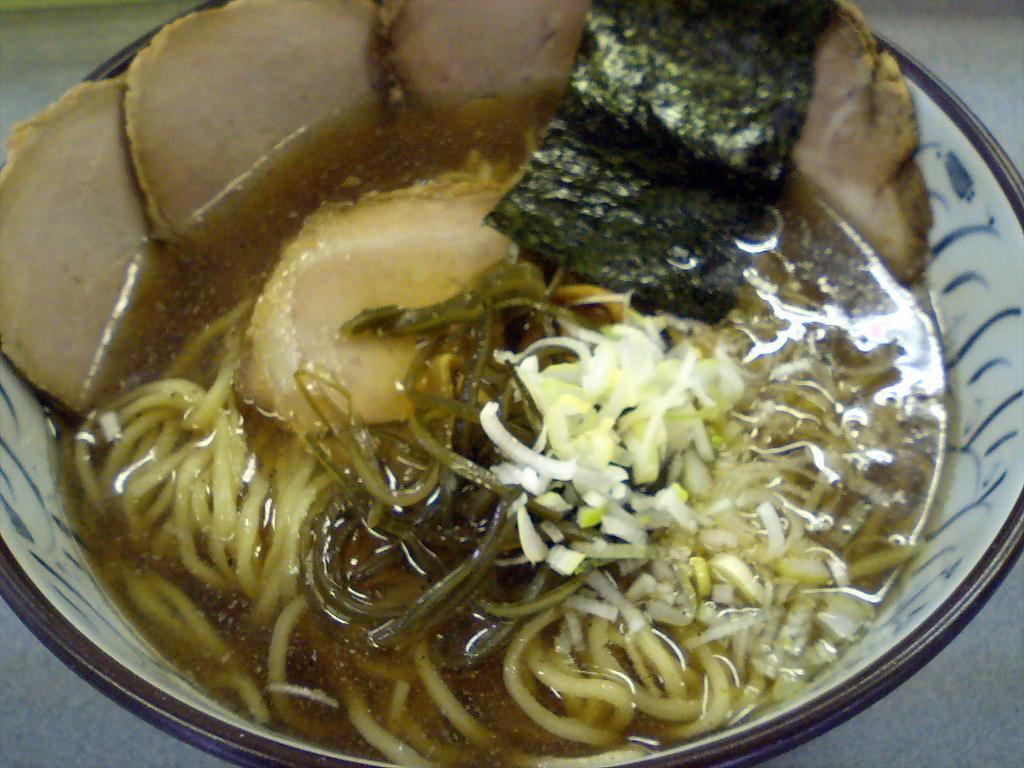Please provide a concise description of this image. In this image, we can see some food item in a bowl. 